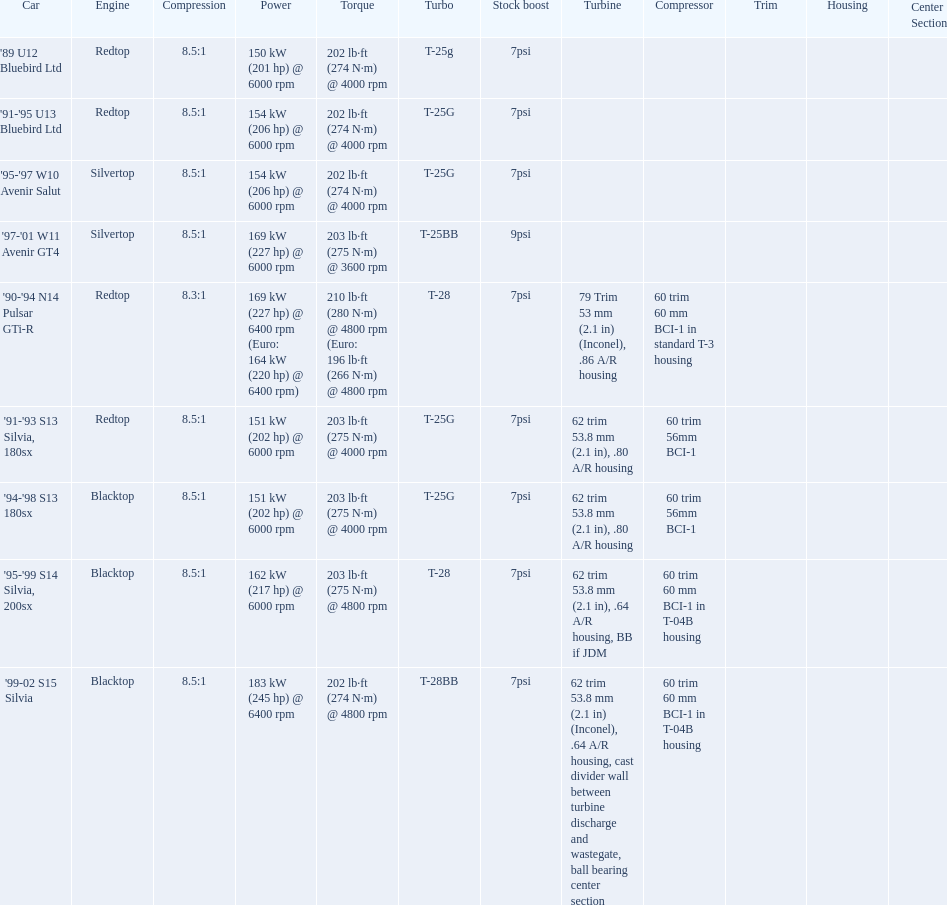Parse the table in full. {'header': ['Car', 'Engine', 'Compression', 'Power', 'Torque', 'Turbo', 'Stock boost', 'Turbine', 'Compressor', 'Trim', 'Housing', 'Center Section'], 'rows': [["'89 U12 Bluebird Ltd", 'Redtop', '8.5:1', '150\xa0kW (201\xa0hp) @ 6000 rpm', '202\xa0lb·ft (274\xa0N·m) @ 4000 rpm', 'T-25g', '7psi', '', '', '', '', ''], ["'91-'95 U13 Bluebird Ltd", 'Redtop', '8.5:1', '154\xa0kW (206\xa0hp) @ 6000 rpm', '202\xa0lb·ft (274\xa0N·m) @ 4000 rpm', 'T-25G', '7psi', '', '', '', '', ''], ["'95-'97 W10 Avenir Salut", 'Silvertop', '8.5:1', '154\xa0kW (206\xa0hp) @ 6000 rpm', '202\xa0lb·ft (274\xa0N·m) @ 4000 rpm', 'T-25G', '7psi', '', '', '', '', ''], ["'97-'01 W11 Avenir GT4", 'Silvertop', '8.5:1', '169\xa0kW (227\xa0hp) @ 6000 rpm', '203\xa0lb·ft (275\xa0N·m) @ 3600 rpm', 'T-25BB', '9psi', '', '', '', '', ''], ["'90-'94 N14 Pulsar GTi-R", 'Redtop', '8.3:1', '169\xa0kW (227\xa0hp) @ 6400 rpm (Euro: 164\xa0kW (220\xa0hp) @ 6400 rpm)', '210\xa0lb·ft (280\xa0N·m) @ 4800 rpm (Euro: 196\xa0lb·ft (266\xa0N·m) @ 4800 rpm', 'T-28', '7psi', '79 Trim 53\xa0mm (2.1\xa0in) (Inconel), .86 A/R housing', '60 trim 60\xa0mm BCI-1 in standard T-3 housing', '', '', ''], ["'91-'93 S13 Silvia, 180sx", 'Redtop', '8.5:1', '151\xa0kW (202\xa0hp) @ 6000 rpm', '203\xa0lb·ft (275\xa0N·m) @ 4000 rpm', 'T-25G', '7psi', '62 trim 53.8\xa0mm (2.1\xa0in), .80 A/R housing', '60 trim 56mm BCI-1', '', '', ''], ["'94-'98 S13 180sx", 'Blacktop', '8.5:1', '151\xa0kW (202\xa0hp) @ 6000 rpm', '203\xa0lb·ft (275\xa0N·m) @ 4000 rpm', 'T-25G', '7psi', '62 trim 53.8\xa0mm (2.1\xa0in), .80 A/R housing', '60 trim 56mm BCI-1', '', '', ''], ["'95-'99 S14 Silvia, 200sx", 'Blacktop', '8.5:1', '162\xa0kW (217\xa0hp) @ 6000 rpm', '203\xa0lb·ft (275\xa0N·m) @ 4800 rpm', 'T-28', '7psi', '62 trim 53.8\xa0mm (2.1\xa0in), .64 A/R housing, BB if JDM', '60 trim 60\xa0mm BCI-1 in T-04B housing', '', '', ''], ["'99-02 S15 Silvia", 'Blacktop', '8.5:1', '183\xa0kW (245\xa0hp) @ 6400 rpm', '202\xa0lb·ft (274\xa0N·m) @ 4800 rpm', 'T-28BB', '7psi', '62 trim 53.8\xa0mm (2.1\xa0in) (Inconel), .64 A/R housing, cast divider wall between turbine discharge and wastegate, ball bearing center section', '60 trim 60\xa0mm BCI-1 in T-04B housing', '', '', '']]} What are the psi's? 7psi, 7psi, 7psi, 9psi, 7psi, 7psi, 7psi, 7psi, 7psi. What are the number(s) greater than 7? 9psi. Which car has that number? '97-'01 W11 Avenir GT4. 